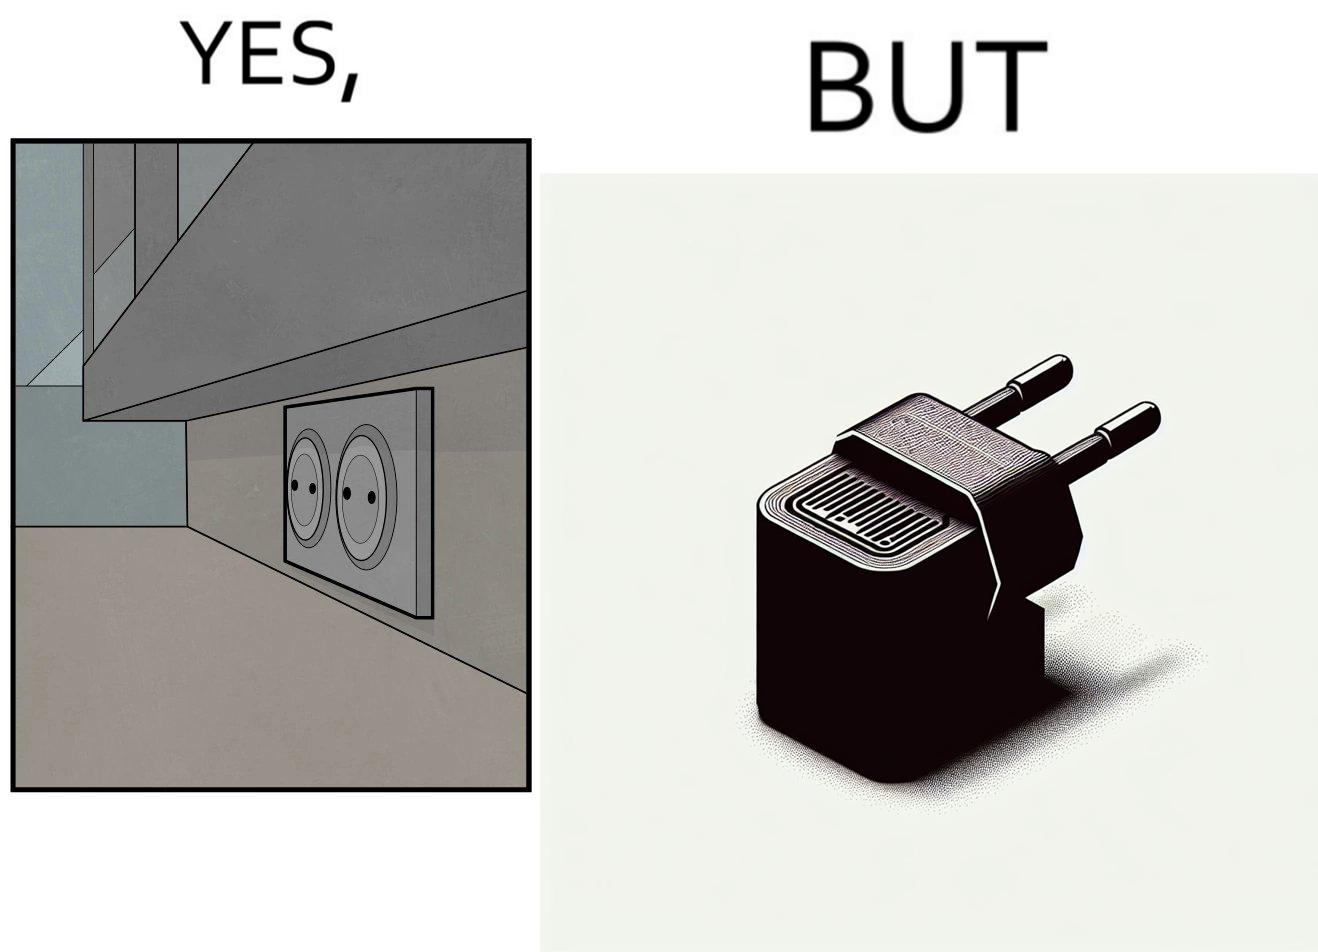Provide a description of this image. The image is funny, as there are two electrical sockets side-by-side, but the adapter is shaped in such a way, that if two adapters are inserted into the two sockets, they will butt into each other, leading to inconvenience. 